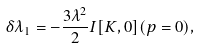Convert formula to latex. <formula><loc_0><loc_0><loc_500><loc_500>\delta \lambda _ { 1 } = - \frac { 3 \lambda ^ { 2 } } 2 I [ K , 0 ] ( p = 0 ) ,</formula> 